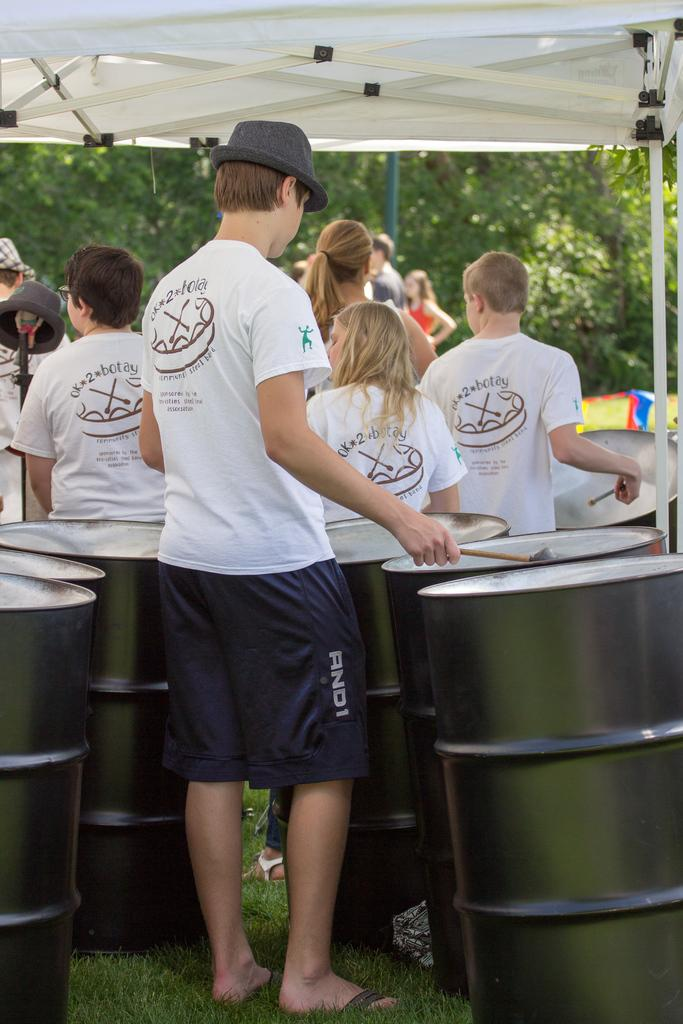Provide a one-sentence caption for the provided image. Several teens wear "OK 2 Botay" shirts at an event. 